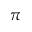<formula> <loc_0><loc_0><loc_500><loc_500>\pi</formula> 